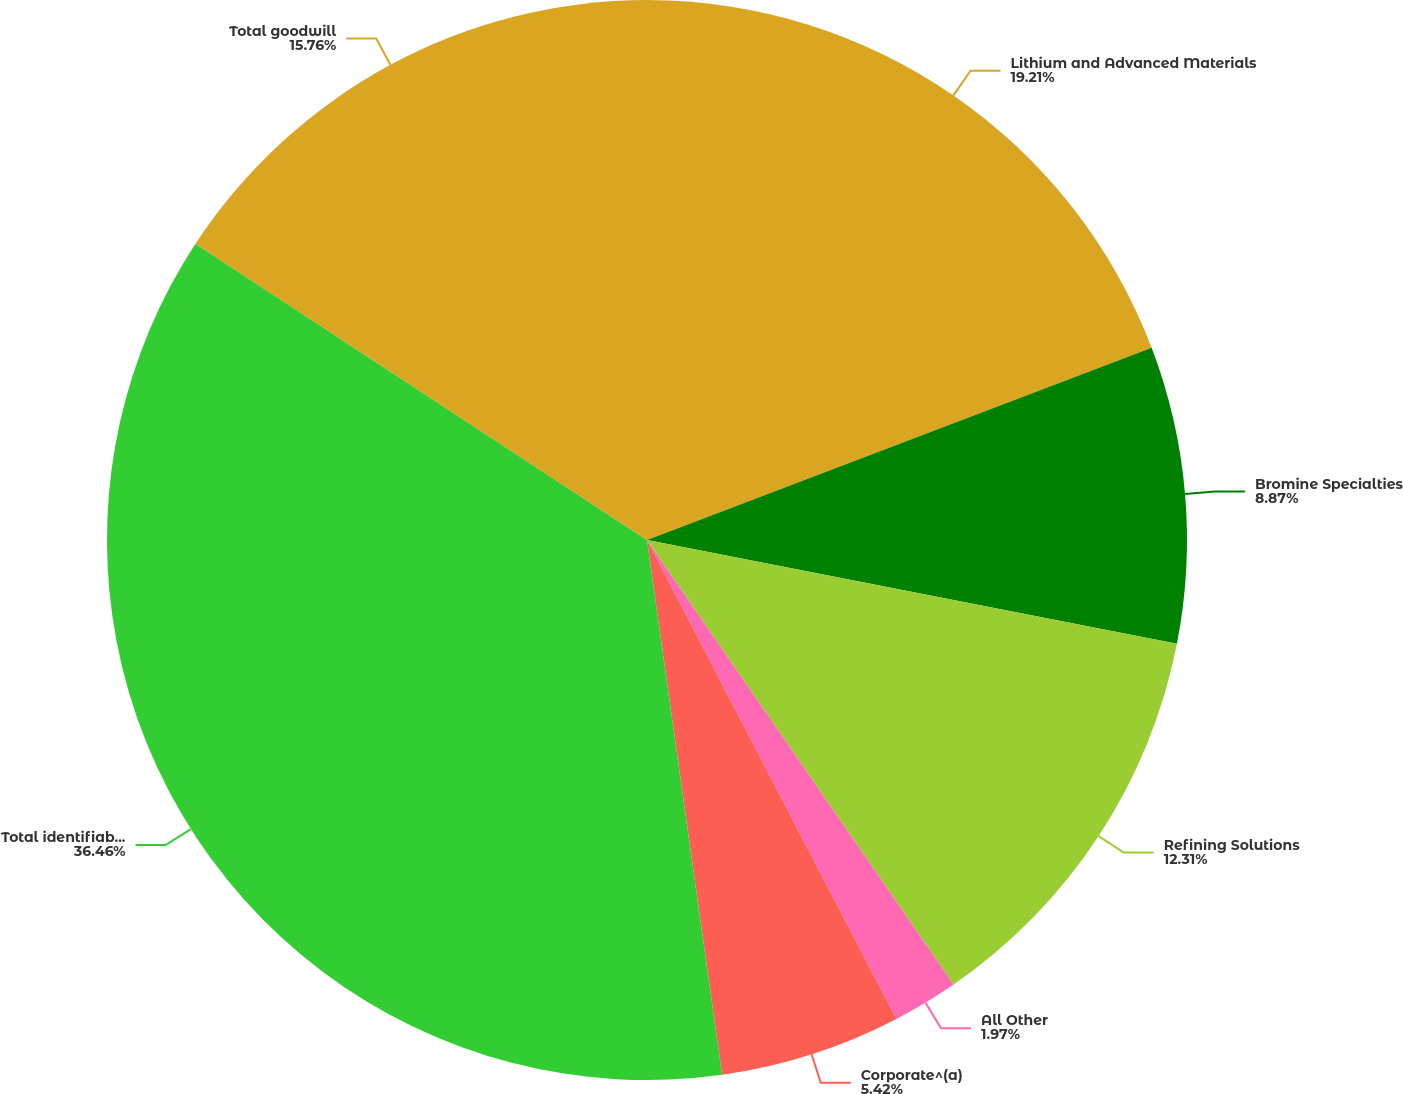<chart> <loc_0><loc_0><loc_500><loc_500><pie_chart><fcel>Lithium and Advanced Materials<fcel>Bromine Specialties<fcel>Refining Solutions<fcel>All Other<fcel>Corporate^(a)<fcel>Total identifiable assets<fcel>Total goodwill<nl><fcel>19.21%<fcel>8.87%<fcel>12.31%<fcel>1.97%<fcel>5.42%<fcel>36.46%<fcel>15.76%<nl></chart> 